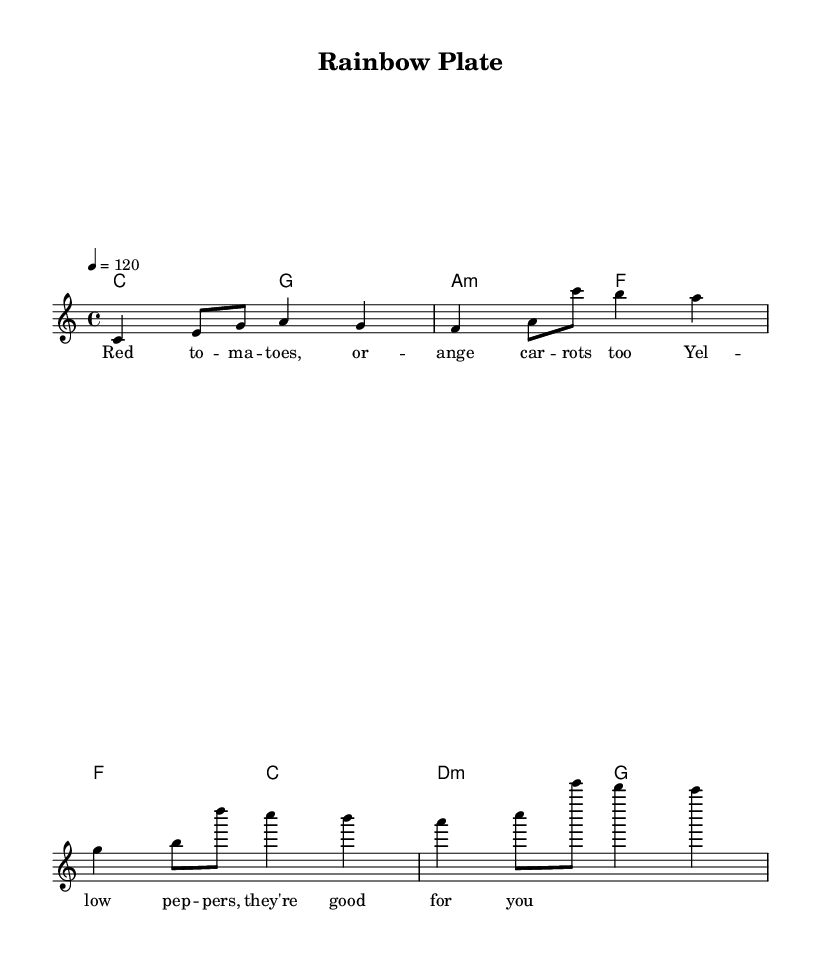What is the key signature of this music? The key signature is based on the intro section of the score, which shows no sharps or flats. This indicates that it is in C major.
Answer: C major What is the time signature of this piece? The time signature is indicated at the beginning of the score, which shows a "4/4" sign, meaning there are four beats in each measure and a quarter note receives one beat.
Answer: 4/4 What is the tempo marking of this music? The tempo marking is found near the top of the score, showing "4 = 120" which means there are 120 beats per minute.
Answer: 120 How many measures are in the melody? The melody consists of eight measures as indicated by counting the segmented group of notes and rests in the melody section.
Answer: 8 What is the first note of the melody? The first note in the melody section is a "C" located in the first measure of the score.
Answer: C What type of lyrics is used in this song? The lyrics are set in a playful manner, focusing on upbeat and colorful references to fruits and vegetables, indicating a theme of nutrition.
Answer: Upbeat Which chords are played in the second measure? The second measure of harmonies indicates that the chord played is "G," as shown in the chord notation for that measure in the score.
Answer: G 